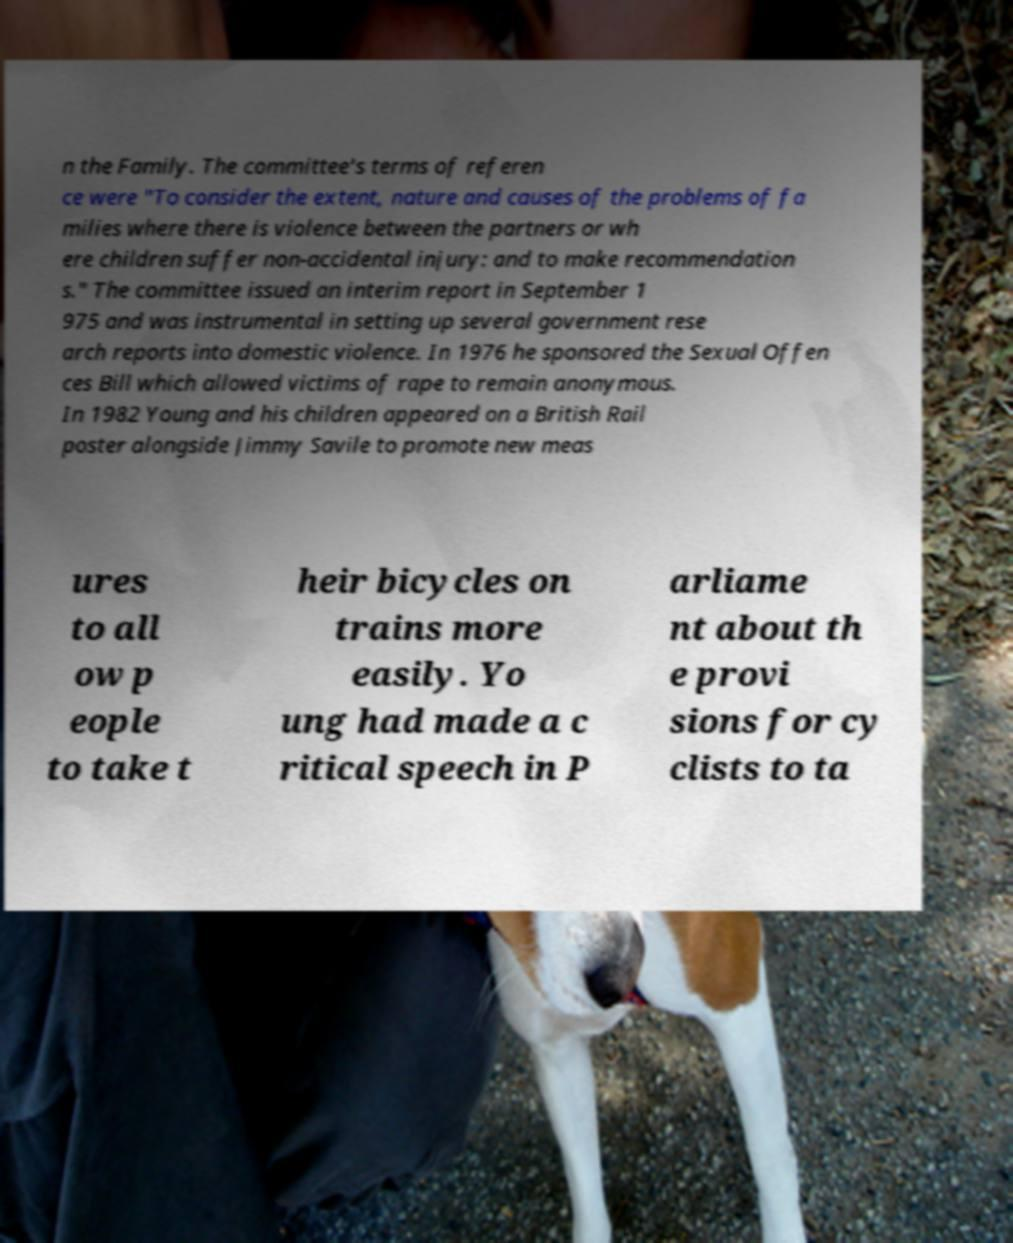Could you assist in decoding the text presented in this image and type it out clearly? n the Family. The committee's terms of referen ce were "To consider the extent, nature and causes of the problems of fa milies where there is violence between the partners or wh ere children suffer non-accidental injury: and to make recommendation s." The committee issued an interim report in September 1 975 and was instrumental in setting up several government rese arch reports into domestic violence. In 1976 he sponsored the Sexual Offen ces Bill which allowed victims of rape to remain anonymous. In 1982 Young and his children appeared on a British Rail poster alongside Jimmy Savile to promote new meas ures to all ow p eople to take t heir bicycles on trains more easily. Yo ung had made a c ritical speech in P arliame nt about th e provi sions for cy clists to ta 